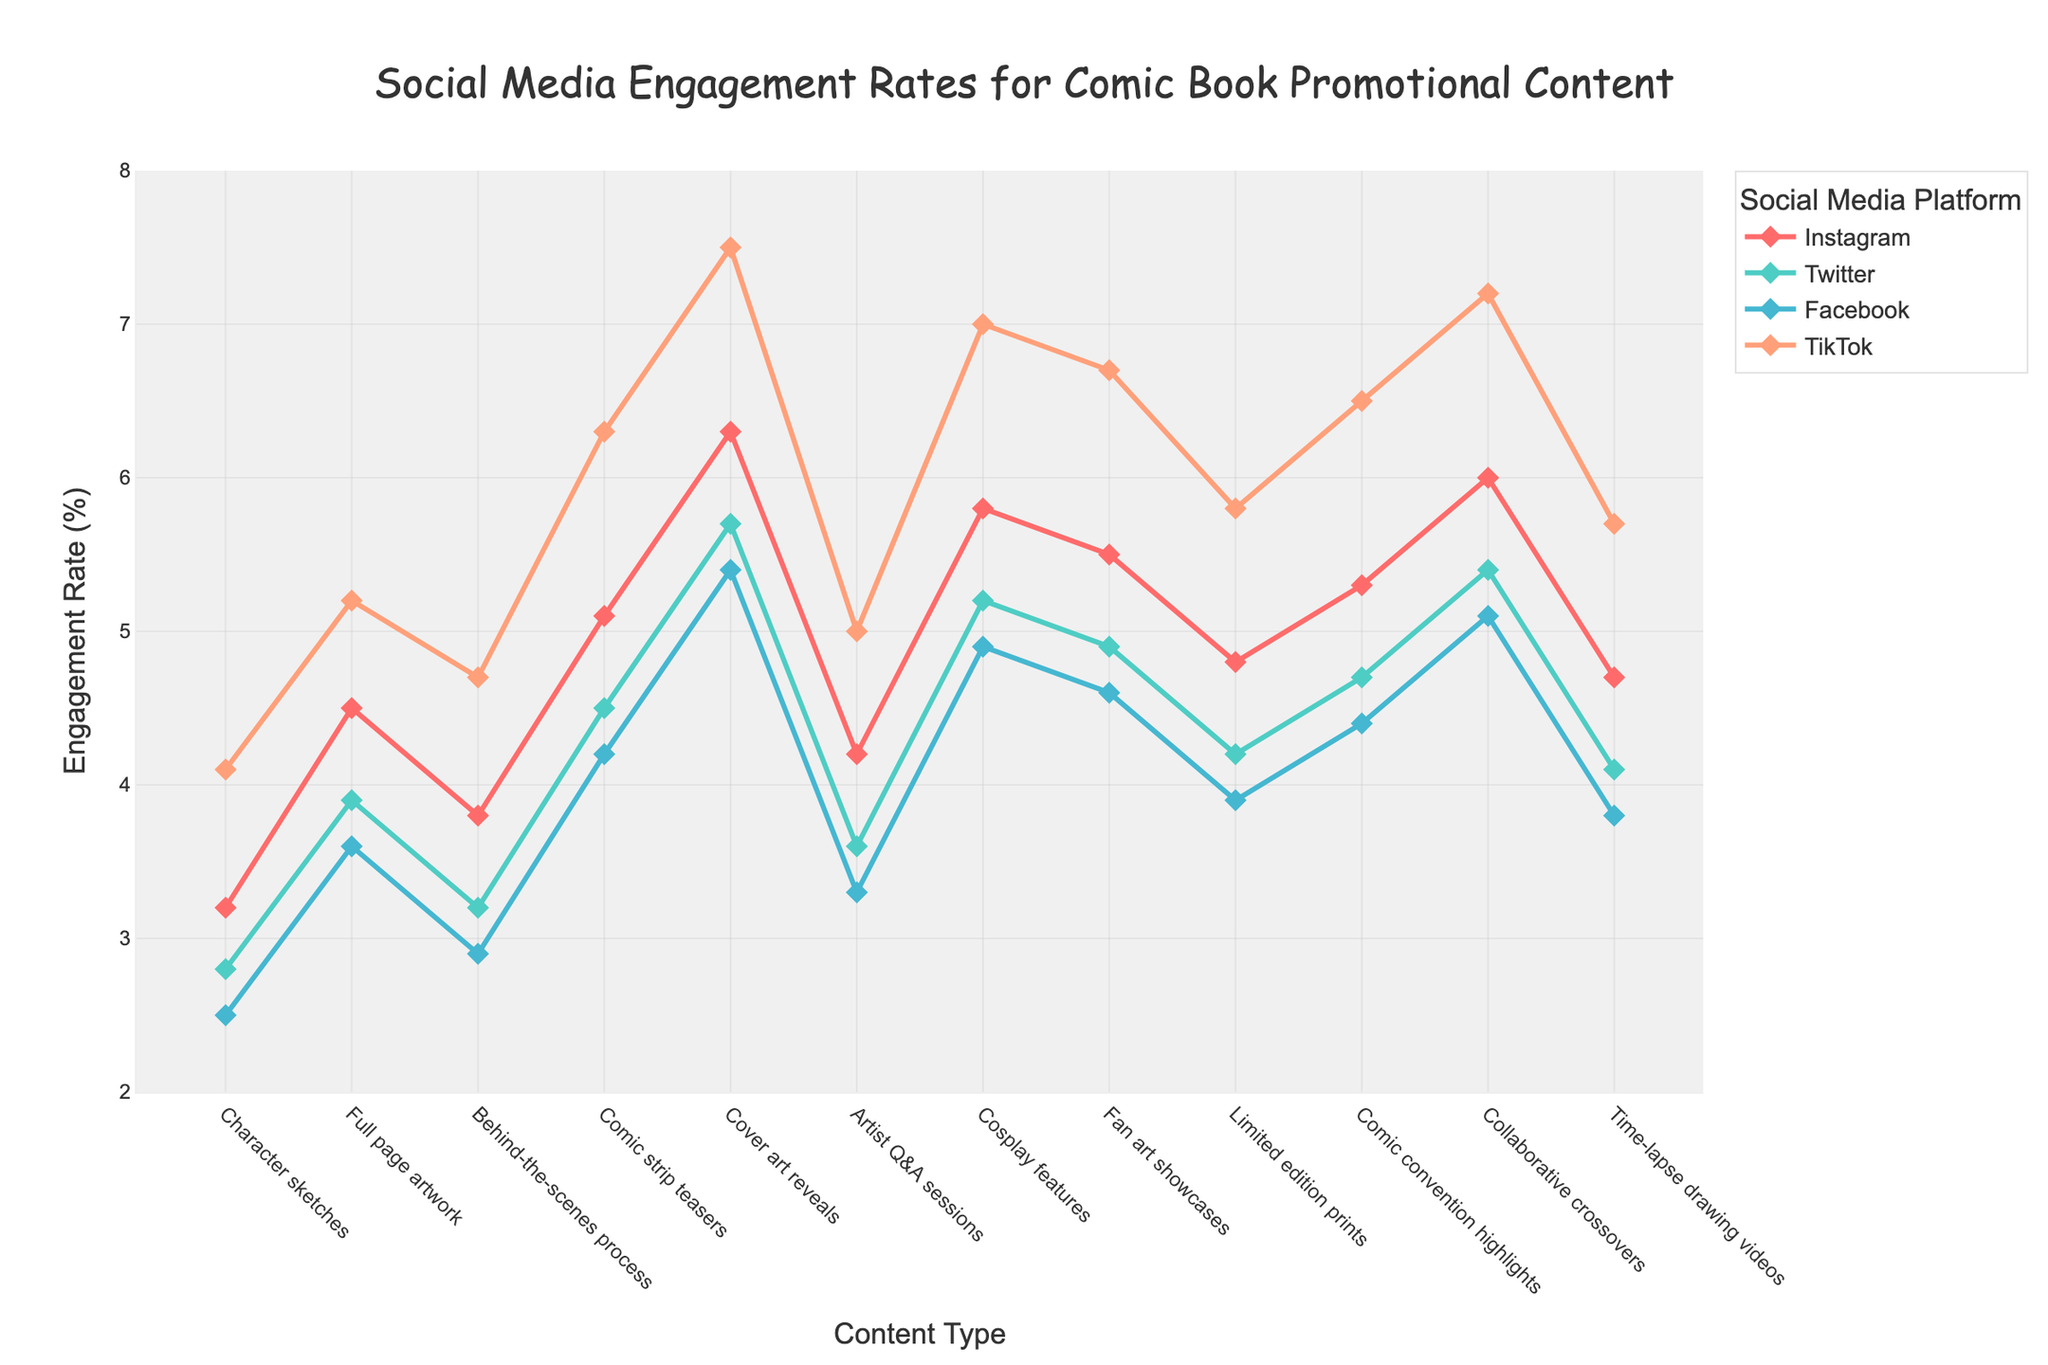Which type of promotional content has the highest engagement rate on Instagram? The plot shows that "Cover art reveals" have the highest engagement rate on Instagram, as indicated by the highest point on the Instagram line.
Answer: Cover art reveals Comparing Twitter and Facebook, which type of content has a greater difference in engagement rates? Inspecting the plot reveals that "Character sketches" have a closer engagement rate on Twitter and Facebook with both being lower than other contents. The greatest difference appears in "Collaborative crossovers" as Twitter is significantly lower than Facebook.
Answer: Collaborative crossovers On which platform do "Comic strip teasers" receive the highest engagement rate? According to the graph, the highest point for "Comic strip teasers" appears in the TikTok series.
Answer: TikTok What is the average engagement rate of "Fan art showcases" across all platforms? Summing the engagement rates for "Fan art showcases" across all platforms and dividing by four: (5.5 + 4.9 + 4.6 + 6.7) / 4 = 5.425
Answer: 5.4 Which types of content have an engagement rate of exactly 4.2 on Facebook? The plot shows that "Artist Q&A sessions" have an engagement rate of exactly 4.2 on Facebook.
Answer: Artist Q&A sessions Which content type has the least engagement rate on TikTok, and what is that rate? Inspecting the TikTok engagement line, "Character sketches" have the least engagement rate on TikTok.
Answer: 4.1 Compare the engagement rates of "Cosplay features" and "Comic convention highlights" on Instagram. Which one is higher and by how much? On Instagram, "Cosplay features" have an engagement rate of 5.8 and "Comic convention highlights" have an engagement rate of 5.3. The difference is 5.8 - 5.3 = 0.5
Answer: Cosplay features, 0.5 What is the total engagement rate for "Cover art reveals" across all platforms? Summing the engagement rates for "Cover art reveals" gives: 6.3 + 5.7 + 5.4 + 7.5 = 24.9
Answer: 24.9 Which platform shows the smallest variance in engagement rates among all the content types? By visually inspecting the graph, the Facebook line appears to have the smallest fluctuations, indicating the least variance.
Answer: Facebook 